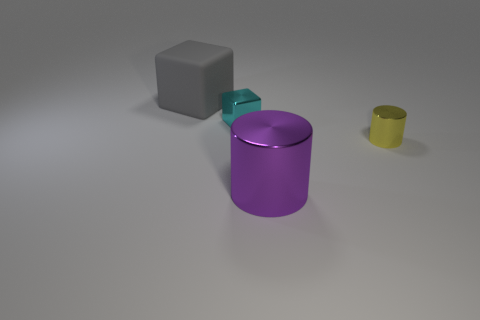Is there any other thing that is made of the same material as the gray block?
Your answer should be compact. No. The object that is in front of the cyan shiny block and behind the large purple cylinder is made of what material?
Your answer should be very brief. Metal. Do the large gray rubber object and the big metal object have the same shape?
Your answer should be compact. No. There is a block that is on the right side of the gray object; is it the same size as the purple metallic object?
Provide a succinct answer. No. There is another tiny object that is the same shape as the rubber object; what color is it?
Your response must be concise. Cyan. What number of objects are either blue metallic cylinders or large cubes?
Provide a succinct answer. 1. What number of small cyan things have the same material as the big purple object?
Provide a succinct answer. 1. Is the number of gray objects less than the number of red rubber cylinders?
Keep it short and to the point. No. Is the material of the large thing that is behind the large purple shiny thing the same as the yellow object?
Offer a terse response. No. How many cubes are large red objects or tiny metal objects?
Offer a very short reply. 1. 